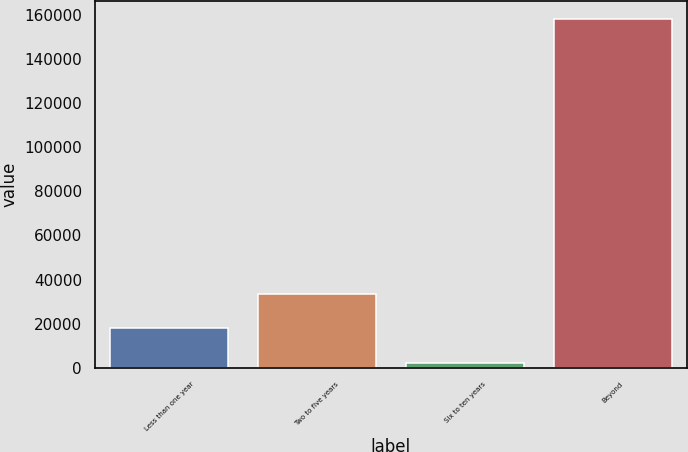Convert chart. <chart><loc_0><loc_0><loc_500><loc_500><bar_chart><fcel>Less than one year<fcel>Two to five years<fcel>Six to ten years<fcel>Beyond<nl><fcel>17912.9<fcel>33497.8<fcel>2328<fcel>158177<nl></chart> 